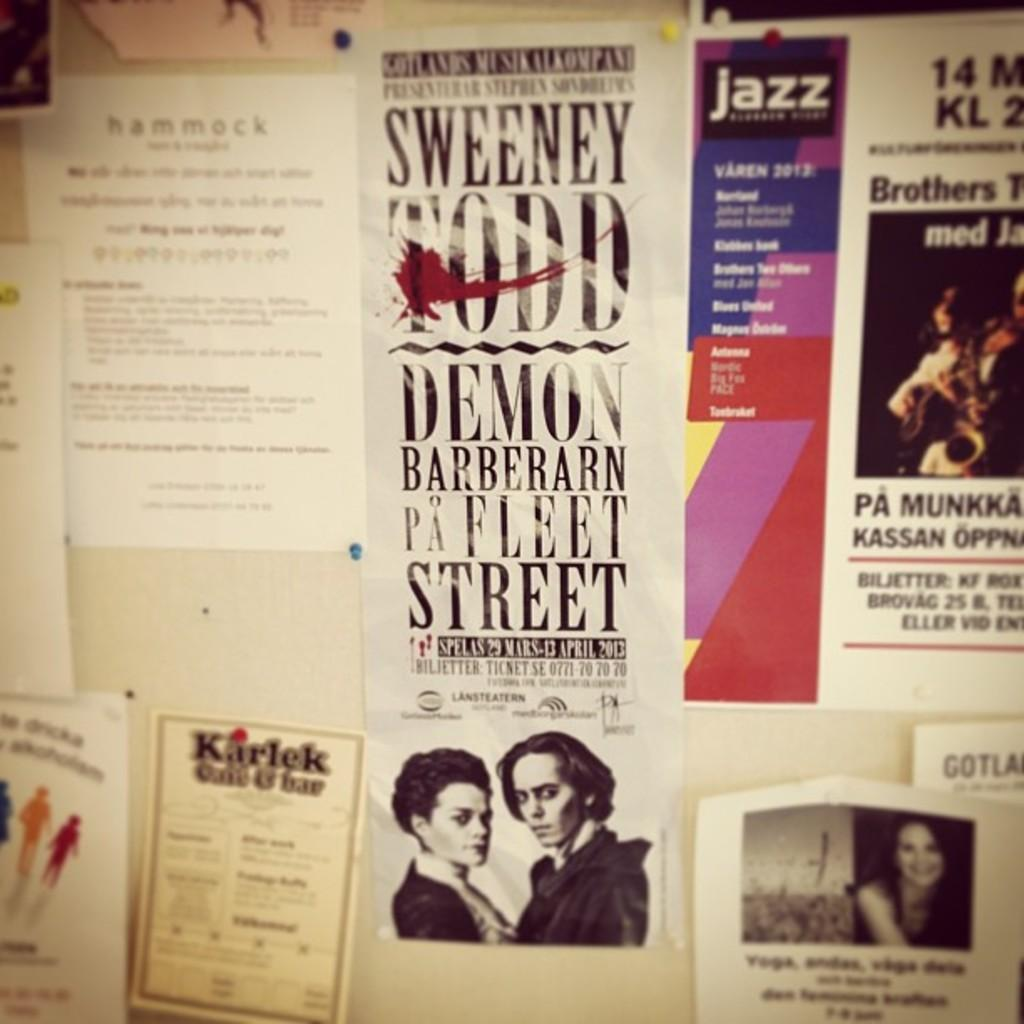<image>
Present a compact description of the photo's key features. A billboard filled with flyers including "Sweeney Todd, Demon Barberarn Pa Fleet Street" 